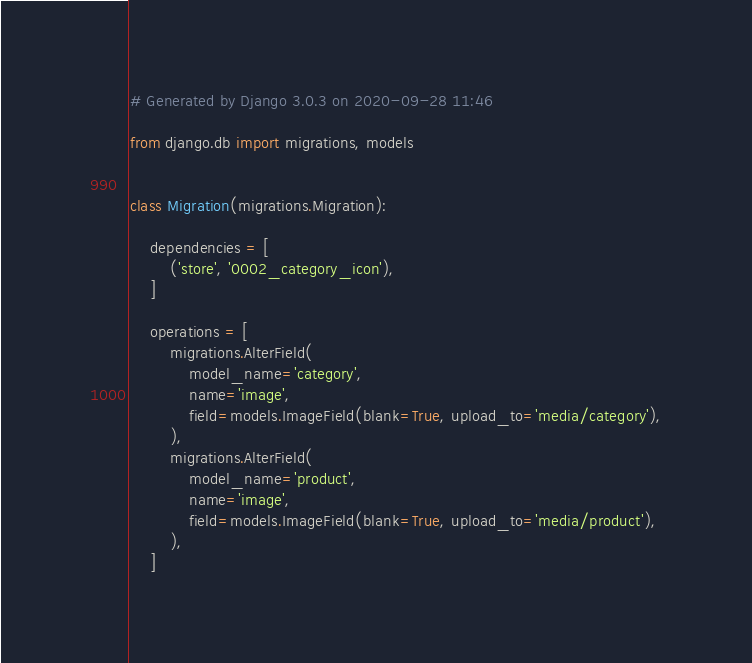Convert code to text. <code><loc_0><loc_0><loc_500><loc_500><_Python_># Generated by Django 3.0.3 on 2020-09-28 11:46

from django.db import migrations, models


class Migration(migrations.Migration):

    dependencies = [
        ('store', '0002_category_icon'),
    ]

    operations = [
        migrations.AlterField(
            model_name='category',
            name='image',
            field=models.ImageField(blank=True, upload_to='media/category'),
        ),
        migrations.AlterField(
            model_name='product',
            name='image',
            field=models.ImageField(blank=True, upload_to='media/product'),
        ),
    ]
</code> 